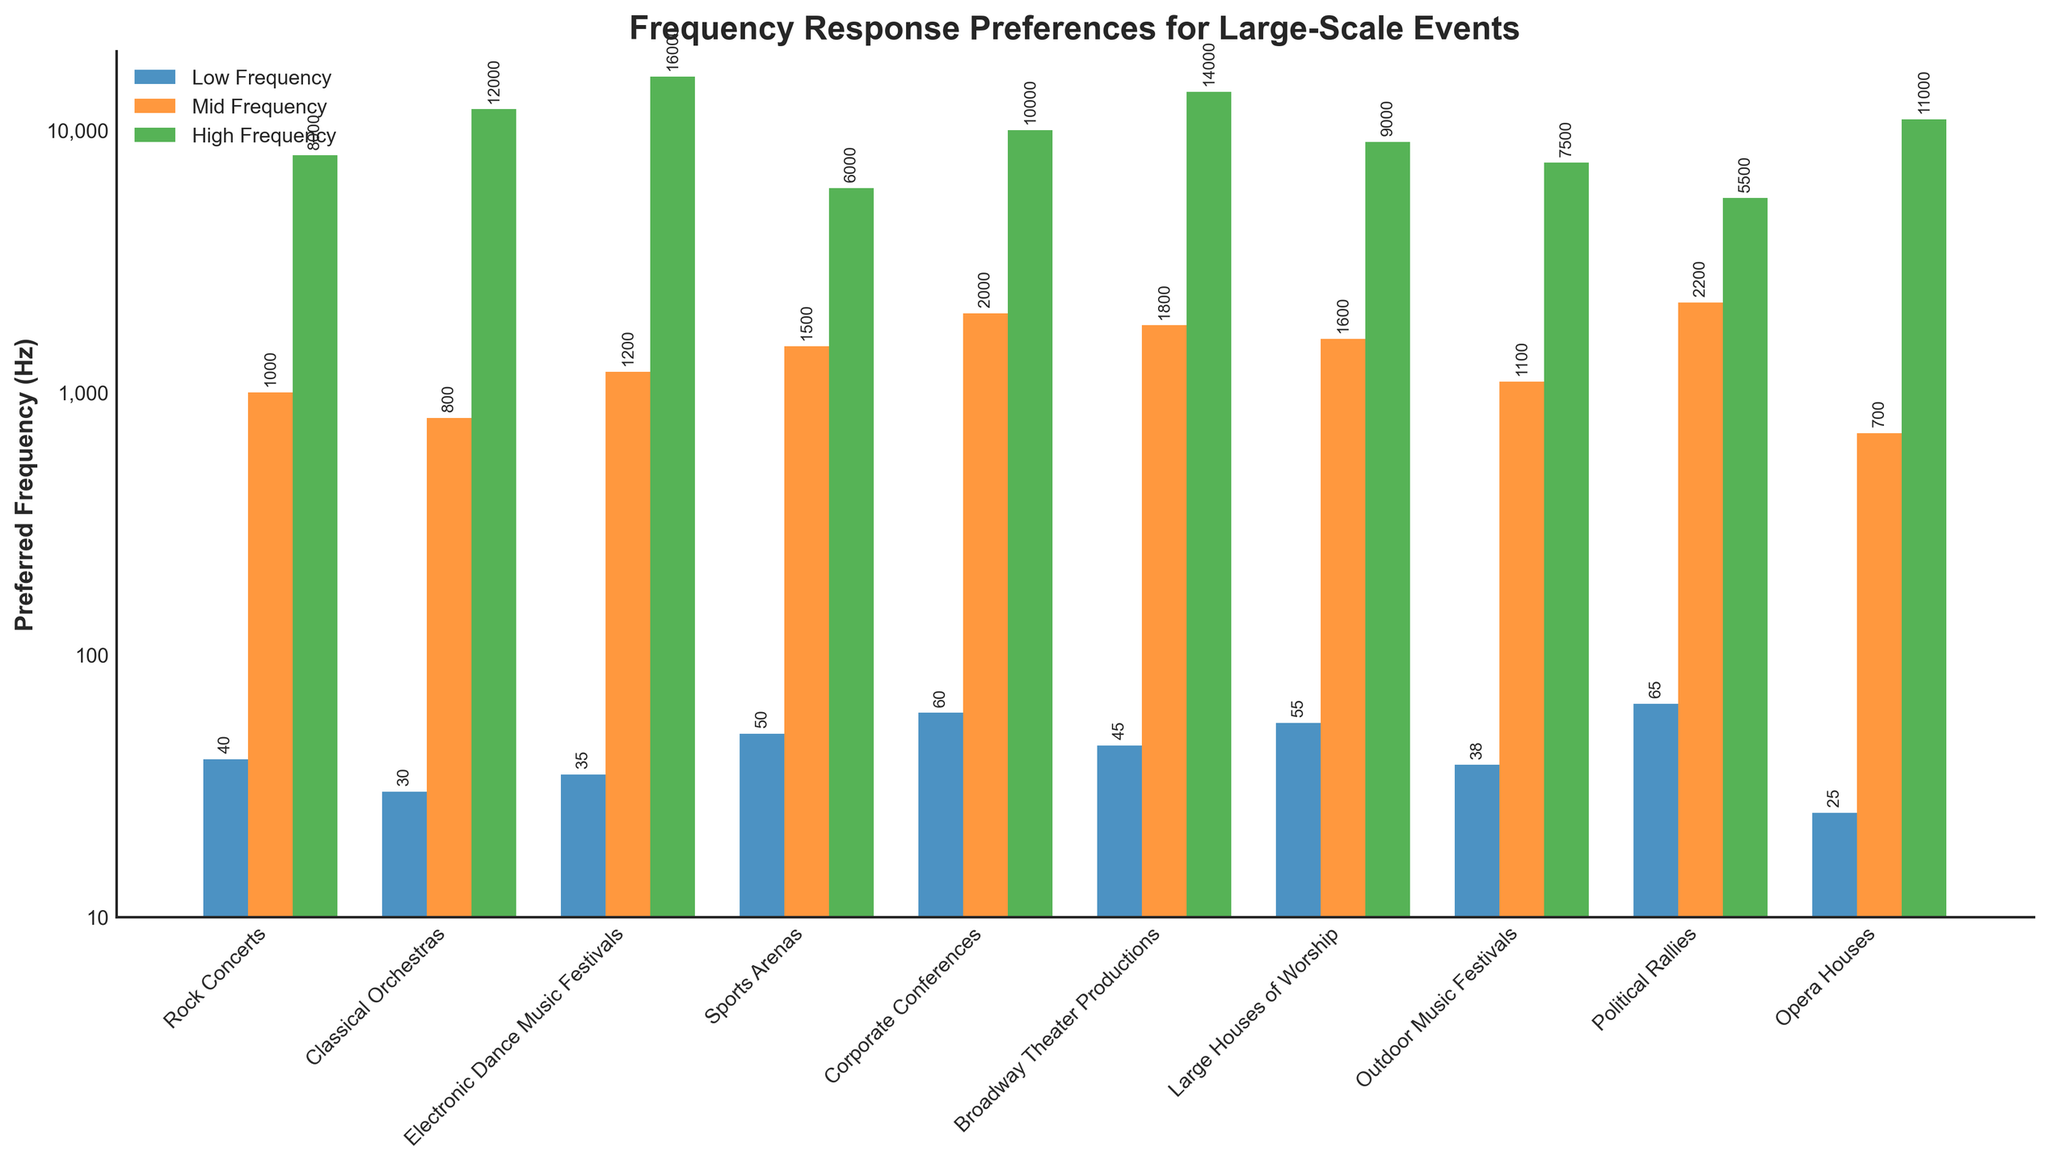Which event type prefers the highest low frequency? Look for the event type with the tallest blue bar, which represents low frequency, and note its value. The Political Rallies bar is tallest at 65 Hz.
Answer: Political Rallies Which event type prefers the lowest high frequency? Locate the event type with the shortest green bar, indicating high frequency, and note its value. Sports Arenas have the lowest high frequency at 6,000 Hz.
Answer: Sports Arenas What is the difference between the highest mid frequency and the lowest mid frequency? Identify the tallest and shortest orange bars for mid frequency. The highest mid frequency is 2,200 Hz (Political Rallies) and the lowest is 700 Hz (Opera Houses). Calculate the difference: 2,200 - 700 = 1,500 Hz.
Answer: 1,500 Hz Which event has an equal or higher low frequency preference compared to its mid frequency preference? Compare the heights of blue and orange bars within each event type. Corporate Conferences have equal low and mid frequency preferences, both being 2,000 Hz.
Answer: Corporate Conferences What is the average mid frequency preference for Rock Concerts, Classical Orchestras, and Electronic Dance Music Festivals? Sum the mid frequencies for these three events: 1,000 Hz (Rock Concerts) + 800 Hz (Classical Orchestras) + 1,200 Hz (Electronic Dance Music Festivals) = 3,000 Hz. Divide by 3: 3,000 / 3 = 1,000 Hz.
Answer: 1,000 Hz 